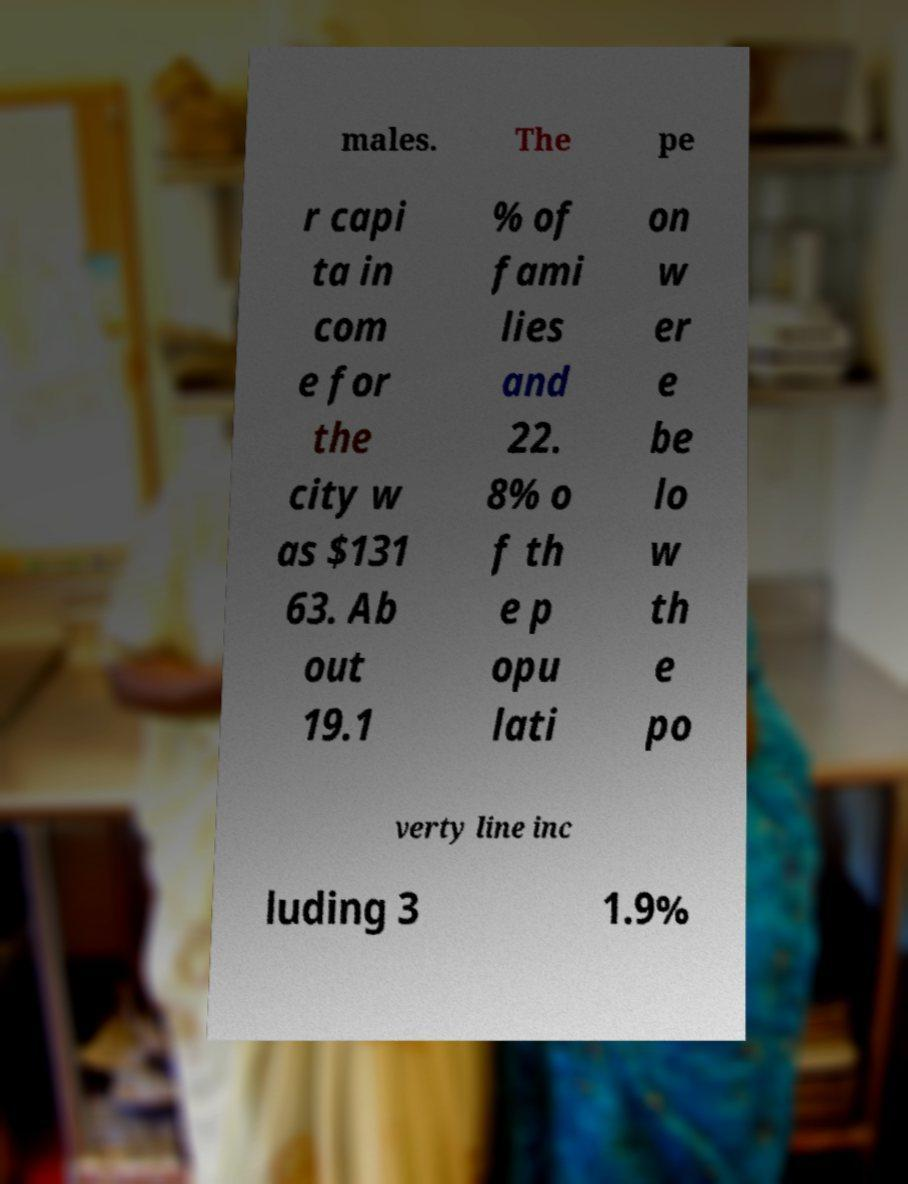Please read and relay the text visible in this image. What does it say? males. The pe r capi ta in com e for the city w as $131 63. Ab out 19.1 % of fami lies and 22. 8% o f th e p opu lati on w er e be lo w th e po verty line inc luding 3 1.9% 